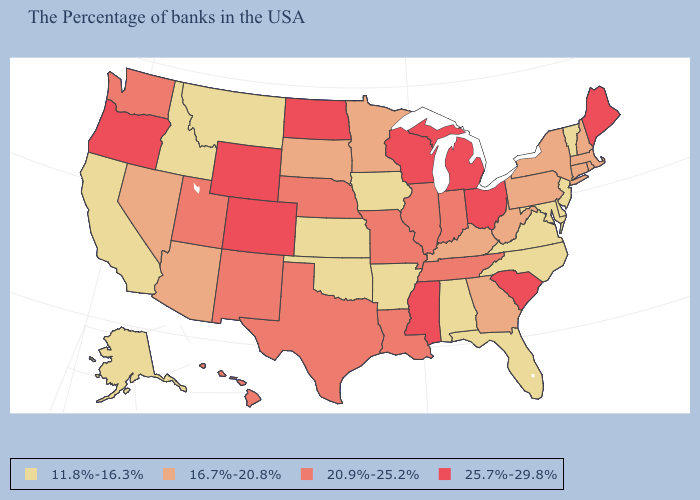What is the highest value in states that border Vermont?
Short answer required. 16.7%-20.8%. Name the states that have a value in the range 11.8%-16.3%?
Answer briefly. Vermont, New Jersey, Delaware, Maryland, Virginia, North Carolina, Florida, Alabama, Arkansas, Iowa, Kansas, Oklahoma, Montana, Idaho, California, Alaska. What is the value of Connecticut?
Give a very brief answer. 16.7%-20.8%. Does Maryland have the lowest value in the USA?
Write a very short answer. Yes. Name the states that have a value in the range 25.7%-29.8%?
Keep it brief. Maine, South Carolina, Ohio, Michigan, Wisconsin, Mississippi, North Dakota, Wyoming, Colorado, Oregon. What is the value of Louisiana?
Be succinct. 20.9%-25.2%. Which states have the lowest value in the USA?
Answer briefly. Vermont, New Jersey, Delaware, Maryland, Virginia, North Carolina, Florida, Alabama, Arkansas, Iowa, Kansas, Oklahoma, Montana, Idaho, California, Alaska. Name the states that have a value in the range 16.7%-20.8%?
Quick response, please. Massachusetts, Rhode Island, New Hampshire, Connecticut, New York, Pennsylvania, West Virginia, Georgia, Kentucky, Minnesota, South Dakota, Arizona, Nevada. Name the states that have a value in the range 25.7%-29.8%?
Short answer required. Maine, South Carolina, Ohio, Michigan, Wisconsin, Mississippi, North Dakota, Wyoming, Colorado, Oregon. Does South Dakota have the highest value in the MidWest?
Give a very brief answer. No. What is the value of Wisconsin?
Quick response, please. 25.7%-29.8%. What is the value of Massachusetts?
Write a very short answer. 16.7%-20.8%. Name the states that have a value in the range 25.7%-29.8%?
Quick response, please. Maine, South Carolina, Ohio, Michigan, Wisconsin, Mississippi, North Dakota, Wyoming, Colorado, Oregon. Does North Dakota have the highest value in the MidWest?
Answer briefly. Yes. 